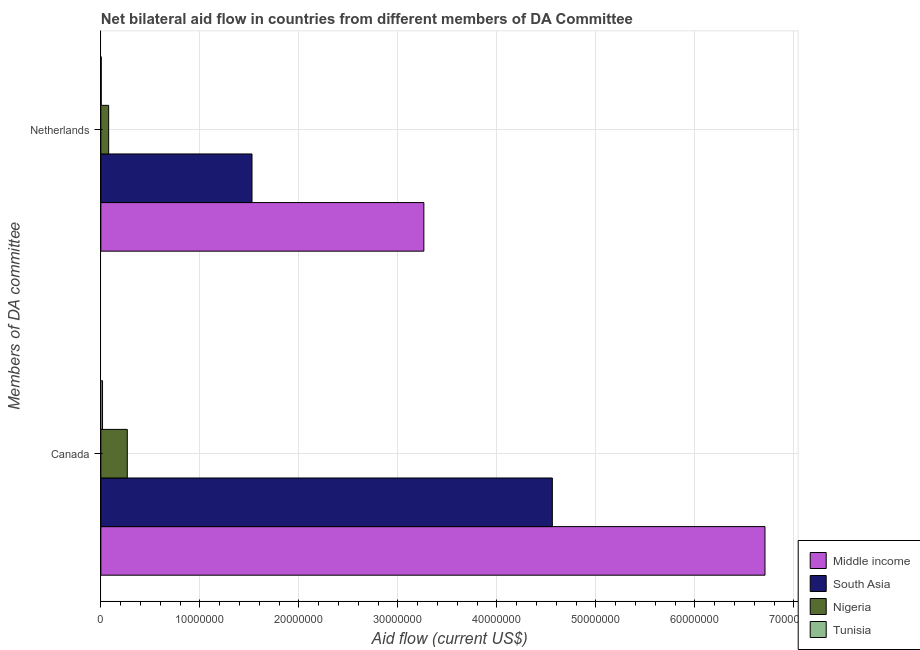How many different coloured bars are there?
Provide a succinct answer. 4. How many groups of bars are there?
Ensure brevity in your answer.  2. What is the label of the 1st group of bars from the top?
Give a very brief answer. Netherlands. What is the amount of aid given by netherlands in Nigeria?
Your answer should be compact. 7.90e+05. Across all countries, what is the maximum amount of aid given by netherlands?
Offer a very short reply. 3.26e+07. Across all countries, what is the minimum amount of aid given by canada?
Your answer should be compact. 1.70e+05. In which country was the amount of aid given by netherlands minimum?
Provide a short and direct response. Tunisia. What is the total amount of aid given by netherlands in the graph?
Your response must be concise. 4.87e+07. What is the difference between the amount of aid given by canada in South Asia and that in Tunisia?
Offer a very short reply. 4.54e+07. What is the difference between the amount of aid given by netherlands in Nigeria and the amount of aid given by canada in Tunisia?
Give a very brief answer. 6.20e+05. What is the average amount of aid given by netherlands per country?
Your answer should be very brief. 1.22e+07. What is the difference between the amount of aid given by canada and amount of aid given by netherlands in Tunisia?
Your response must be concise. 1.30e+05. What is the ratio of the amount of aid given by netherlands in Nigeria to that in Middle income?
Provide a succinct answer. 0.02. Is the amount of aid given by netherlands in South Asia less than that in Nigeria?
Ensure brevity in your answer.  No. What does the 1st bar from the top in Canada represents?
Provide a succinct answer. Tunisia. What does the 3rd bar from the bottom in Netherlands represents?
Offer a terse response. Nigeria. How many bars are there?
Offer a very short reply. 8. How many countries are there in the graph?
Keep it short and to the point. 4. What is the difference between two consecutive major ticks on the X-axis?
Give a very brief answer. 1.00e+07. Does the graph contain grids?
Provide a succinct answer. Yes. Where does the legend appear in the graph?
Provide a succinct answer. Bottom right. How many legend labels are there?
Ensure brevity in your answer.  4. How are the legend labels stacked?
Make the answer very short. Vertical. What is the title of the graph?
Provide a short and direct response. Net bilateral aid flow in countries from different members of DA Committee. What is the label or title of the X-axis?
Your answer should be compact. Aid flow (current US$). What is the label or title of the Y-axis?
Give a very brief answer. Members of DA committee. What is the Aid flow (current US$) of Middle income in Canada?
Your answer should be very brief. 6.71e+07. What is the Aid flow (current US$) in South Asia in Canada?
Your answer should be very brief. 4.56e+07. What is the Aid flow (current US$) of Nigeria in Canada?
Keep it short and to the point. 2.67e+06. What is the Aid flow (current US$) of Middle income in Netherlands?
Keep it short and to the point. 3.26e+07. What is the Aid flow (current US$) in South Asia in Netherlands?
Ensure brevity in your answer.  1.53e+07. What is the Aid flow (current US$) in Nigeria in Netherlands?
Offer a terse response. 7.90e+05. What is the Aid flow (current US$) in Tunisia in Netherlands?
Your response must be concise. 4.00e+04. Across all Members of DA committee, what is the maximum Aid flow (current US$) of Middle income?
Your response must be concise. 6.71e+07. Across all Members of DA committee, what is the maximum Aid flow (current US$) of South Asia?
Provide a succinct answer. 4.56e+07. Across all Members of DA committee, what is the maximum Aid flow (current US$) in Nigeria?
Provide a succinct answer. 2.67e+06. Across all Members of DA committee, what is the minimum Aid flow (current US$) of Middle income?
Offer a terse response. 3.26e+07. Across all Members of DA committee, what is the minimum Aid flow (current US$) in South Asia?
Provide a short and direct response. 1.53e+07. Across all Members of DA committee, what is the minimum Aid flow (current US$) in Nigeria?
Provide a succinct answer. 7.90e+05. Across all Members of DA committee, what is the minimum Aid flow (current US$) of Tunisia?
Your answer should be compact. 4.00e+04. What is the total Aid flow (current US$) of Middle income in the graph?
Make the answer very short. 9.97e+07. What is the total Aid flow (current US$) in South Asia in the graph?
Your answer should be compact. 6.09e+07. What is the total Aid flow (current US$) in Nigeria in the graph?
Ensure brevity in your answer.  3.46e+06. What is the difference between the Aid flow (current US$) in Middle income in Canada and that in Netherlands?
Your answer should be compact. 3.45e+07. What is the difference between the Aid flow (current US$) in South Asia in Canada and that in Netherlands?
Provide a succinct answer. 3.03e+07. What is the difference between the Aid flow (current US$) of Nigeria in Canada and that in Netherlands?
Your answer should be very brief. 1.88e+06. What is the difference between the Aid flow (current US$) of Tunisia in Canada and that in Netherlands?
Offer a very short reply. 1.30e+05. What is the difference between the Aid flow (current US$) of Middle income in Canada and the Aid flow (current US$) of South Asia in Netherlands?
Provide a succinct answer. 5.18e+07. What is the difference between the Aid flow (current US$) of Middle income in Canada and the Aid flow (current US$) of Nigeria in Netherlands?
Your answer should be compact. 6.63e+07. What is the difference between the Aid flow (current US$) in Middle income in Canada and the Aid flow (current US$) in Tunisia in Netherlands?
Provide a succinct answer. 6.70e+07. What is the difference between the Aid flow (current US$) in South Asia in Canada and the Aid flow (current US$) in Nigeria in Netherlands?
Make the answer very short. 4.48e+07. What is the difference between the Aid flow (current US$) in South Asia in Canada and the Aid flow (current US$) in Tunisia in Netherlands?
Provide a succinct answer. 4.56e+07. What is the difference between the Aid flow (current US$) in Nigeria in Canada and the Aid flow (current US$) in Tunisia in Netherlands?
Provide a short and direct response. 2.63e+06. What is the average Aid flow (current US$) of Middle income per Members of DA committee?
Provide a succinct answer. 4.99e+07. What is the average Aid flow (current US$) in South Asia per Members of DA committee?
Provide a succinct answer. 3.04e+07. What is the average Aid flow (current US$) of Nigeria per Members of DA committee?
Give a very brief answer. 1.73e+06. What is the average Aid flow (current US$) in Tunisia per Members of DA committee?
Ensure brevity in your answer.  1.05e+05. What is the difference between the Aid flow (current US$) of Middle income and Aid flow (current US$) of South Asia in Canada?
Your answer should be very brief. 2.15e+07. What is the difference between the Aid flow (current US$) in Middle income and Aid flow (current US$) in Nigeria in Canada?
Keep it short and to the point. 6.44e+07. What is the difference between the Aid flow (current US$) of Middle income and Aid flow (current US$) of Tunisia in Canada?
Ensure brevity in your answer.  6.69e+07. What is the difference between the Aid flow (current US$) of South Asia and Aid flow (current US$) of Nigeria in Canada?
Offer a very short reply. 4.29e+07. What is the difference between the Aid flow (current US$) in South Asia and Aid flow (current US$) in Tunisia in Canada?
Your response must be concise. 4.54e+07. What is the difference between the Aid flow (current US$) in Nigeria and Aid flow (current US$) in Tunisia in Canada?
Your response must be concise. 2.50e+06. What is the difference between the Aid flow (current US$) of Middle income and Aid flow (current US$) of South Asia in Netherlands?
Keep it short and to the point. 1.74e+07. What is the difference between the Aid flow (current US$) in Middle income and Aid flow (current US$) in Nigeria in Netherlands?
Offer a terse response. 3.18e+07. What is the difference between the Aid flow (current US$) of Middle income and Aid flow (current US$) of Tunisia in Netherlands?
Your answer should be very brief. 3.26e+07. What is the difference between the Aid flow (current US$) in South Asia and Aid flow (current US$) in Nigeria in Netherlands?
Provide a short and direct response. 1.45e+07. What is the difference between the Aid flow (current US$) of South Asia and Aid flow (current US$) of Tunisia in Netherlands?
Offer a very short reply. 1.52e+07. What is the difference between the Aid flow (current US$) in Nigeria and Aid flow (current US$) in Tunisia in Netherlands?
Your answer should be compact. 7.50e+05. What is the ratio of the Aid flow (current US$) of Middle income in Canada to that in Netherlands?
Offer a very short reply. 2.06. What is the ratio of the Aid flow (current US$) in South Asia in Canada to that in Netherlands?
Provide a succinct answer. 2.99. What is the ratio of the Aid flow (current US$) in Nigeria in Canada to that in Netherlands?
Ensure brevity in your answer.  3.38. What is the ratio of the Aid flow (current US$) in Tunisia in Canada to that in Netherlands?
Give a very brief answer. 4.25. What is the difference between the highest and the second highest Aid flow (current US$) in Middle income?
Your answer should be very brief. 3.45e+07. What is the difference between the highest and the second highest Aid flow (current US$) in South Asia?
Your answer should be compact. 3.03e+07. What is the difference between the highest and the second highest Aid flow (current US$) of Nigeria?
Keep it short and to the point. 1.88e+06. What is the difference between the highest and the second highest Aid flow (current US$) in Tunisia?
Provide a short and direct response. 1.30e+05. What is the difference between the highest and the lowest Aid flow (current US$) in Middle income?
Make the answer very short. 3.45e+07. What is the difference between the highest and the lowest Aid flow (current US$) of South Asia?
Provide a short and direct response. 3.03e+07. What is the difference between the highest and the lowest Aid flow (current US$) in Nigeria?
Your response must be concise. 1.88e+06. What is the difference between the highest and the lowest Aid flow (current US$) of Tunisia?
Your answer should be compact. 1.30e+05. 